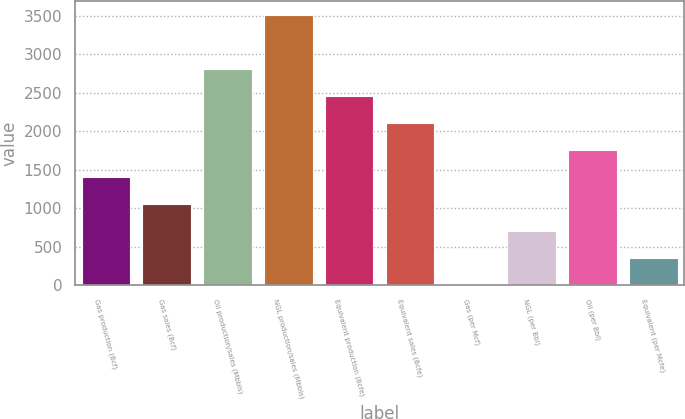Convert chart. <chart><loc_0><loc_0><loc_500><loc_500><bar_chart><fcel>Gas production (Bcf)<fcel>Gas sales (Bcf)<fcel>Oil production/sales (Mbbls)<fcel>NGL production/sales (Mbbls)<fcel>Equivalent production (Bcfe)<fcel>Equivalent sales (Bcfe)<fcel>Gas (per Mcf)<fcel>NGL (per Bbl)<fcel>Oil (per Bbl)<fcel>Equivalent (per Mcfe)<nl><fcel>1407.92<fcel>1058.01<fcel>2807.59<fcel>3507.4<fcel>2457.68<fcel>2107.76<fcel>8.25<fcel>708.09<fcel>1757.84<fcel>358.17<nl></chart> 